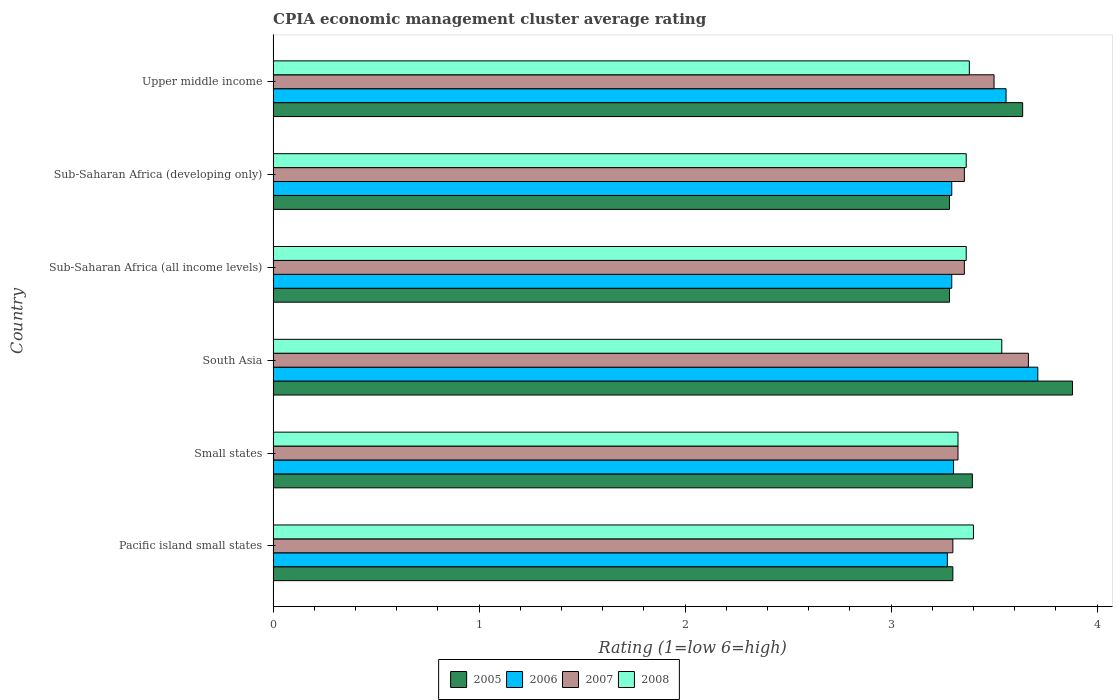How many different coloured bars are there?
Make the answer very short. 4. Are the number of bars per tick equal to the number of legend labels?
Make the answer very short. Yes. What is the label of the 2nd group of bars from the top?
Provide a succinct answer. Sub-Saharan Africa (developing only). What is the CPIA rating in 2008 in Small states?
Your response must be concise. 3.33. Across all countries, what is the maximum CPIA rating in 2008?
Offer a terse response. 3.54. Across all countries, what is the minimum CPIA rating in 2008?
Ensure brevity in your answer.  3.33. In which country was the CPIA rating in 2008 maximum?
Keep it short and to the point. South Asia. In which country was the CPIA rating in 2006 minimum?
Your answer should be compact. Pacific island small states. What is the total CPIA rating in 2006 in the graph?
Your response must be concise. 20.44. What is the difference between the CPIA rating in 2008 in Small states and that in Sub-Saharan Africa (developing only)?
Make the answer very short. -0.04. What is the difference between the CPIA rating in 2006 in South Asia and the CPIA rating in 2008 in Small states?
Offer a very short reply. 0.39. What is the average CPIA rating in 2007 per country?
Your response must be concise. 3.42. What is the difference between the CPIA rating in 2007 and CPIA rating in 2008 in Sub-Saharan Africa (all income levels)?
Offer a terse response. -0.01. In how many countries, is the CPIA rating in 2008 greater than 2.8 ?
Keep it short and to the point. 6. What is the ratio of the CPIA rating in 2006 in Small states to that in Upper middle income?
Your answer should be compact. 0.93. Is the difference between the CPIA rating in 2007 in South Asia and Upper middle income greater than the difference between the CPIA rating in 2008 in South Asia and Upper middle income?
Your answer should be very brief. Yes. What is the difference between the highest and the second highest CPIA rating in 2006?
Offer a very short reply. 0.15. What is the difference between the highest and the lowest CPIA rating in 2006?
Your response must be concise. 0.44. Is it the case that in every country, the sum of the CPIA rating in 2008 and CPIA rating in 2006 is greater than the sum of CPIA rating in 2007 and CPIA rating in 2005?
Your answer should be very brief. No. What does the 2nd bar from the top in Pacific island small states represents?
Your response must be concise. 2007. Is it the case that in every country, the sum of the CPIA rating in 2007 and CPIA rating in 2005 is greater than the CPIA rating in 2008?
Ensure brevity in your answer.  Yes. Where does the legend appear in the graph?
Offer a very short reply. Bottom center. How are the legend labels stacked?
Provide a short and direct response. Horizontal. What is the title of the graph?
Your response must be concise. CPIA economic management cluster average rating. Does "1998" appear as one of the legend labels in the graph?
Offer a terse response. No. What is the label or title of the Y-axis?
Your response must be concise. Country. What is the Rating (1=low 6=high) of 2006 in Pacific island small states?
Your answer should be compact. 3.27. What is the Rating (1=low 6=high) of 2005 in Small states?
Provide a short and direct response. 3.39. What is the Rating (1=low 6=high) of 2006 in Small states?
Your answer should be compact. 3.3. What is the Rating (1=low 6=high) of 2007 in Small states?
Your answer should be very brief. 3.33. What is the Rating (1=low 6=high) of 2008 in Small states?
Provide a short and direct response. 3.33. What is the Rating (1=low 6=high) in 2005 in South Asia?
Make the answer very short. 3.88. What is the Rating (1=low 6=high) of 2006 in South Asia?
Provide a short and direct response. 3.71. What is the Rating (1=low 6=high) in 2007 in South Asia?
Provide a short and direct response. 3.67. What is the Rating (1=low 6=high) in 2008 in South Asia?
Your response must be concise. 3.54. What is the Rating (1=low 6=high) in 2005 in Sub-Saharan Africa (all income levels)?
Ensure brevity in your answer.  3.28. What is the Rating (1=low 6=high) in 2006 in Sub-Saharan Africa (all income levels)?
Your answer should be very brief. 3.29. What is the Rating (1=low 6=high) in 2007 in Sub-Saharan Africa (all income levels)?
Keep it short and to the point. 3.36. What is the Rating (1=low 6=high) in 2008 in Sub-Saharan Africa (all income levels)?
Provide a short and direct response. 3.36. What is the Rating (1=low 6=high) of 2005 in Sub-Saharan Africa (developing only)?
Provide a short and direct response. 3.28. What is the Rating (1=low 6=high) of 2006 in Sub-Saharan Africa (developing only)?
Keep it short and to the point. 3.29. What is the Rating (1=low 6=high) of 2007 in Sub-Saharan Africa (developing only)?
Keep it short and to the point. 3.36. What is the Rating (1=low 6=high) of 2008 in Sub-Saharan Africa (developing only)?
Offer a very short reply. 3.36. What is the Rating (1=low 6=high) in 2005 in Upper middle income?
Your answer should be compact. 3.64. What is the Rating (1=low 6=high) in 2006 in Upper middle income?
Your answer should be very brief. 3.56. What is the Rating (1=low 6=high) of 2008 in Upper middle income?
Provide a succinct answer. 3.38. Across all countries, what is the maximum Rating (1=low 6=high) of 2005?
Provide a short and direct response. 3.88. Across all countries, what is the maximum Rating (1=low 6=high) of 2006?
Your response must be concise. 3.71. Across all countries, what is the maximum Rating (1=low 6=high) of 2007?
Give a very brief answer. 3.67. Across all countries, what is the maximum Rating (1=low 6=high) in 2008?
Offer a very short reply. 3.54. Across all countries, what is the minimum Rating (1=low 6=high) in 2005?
Your answer should be compact. 3.28. Across all countries, what is the minimum Rating (1=low 6=high) in 2006?
Offer a very short reply. 3.27. Across all countries, what is the minimum Rating (1=low 6=high) of 2008?
Provide a short and direct response. 3.33. What is the total Rating (1=low 6=high) in 2005 in the graph?
Provide a short and direct response. 20.78. What is the total Rating (1=low 6=high) in 2006 in the graph?
Your answer should be compact. 20.44. What is the total Rating (1=low 6=high) in 2007 in the graph?
Your answer should be compact. 20.5. What is the total Rating (1=low 6=high) in 2008 in the graph?
Your response must be concise. 20.37. What is the difference between the Rating (1=low 6=high) of 2005 in Pacific island small states and that in Small states?
Provide a succinct answer. -0.09. What is the difference between the Rating (1=low 6=high) in 2006 in Pacific island small states and that in Small states?
Provide a short and direct response. -0.03. What is the difference between the Rating (1=low 6=high) of 2007 in Pacific island small states and that in Small states?
Your response must be concise. -0.03. What is the difference between the Rating (1=low 6=high) in 2008 in Pacific island small states and that in Small states?
Provide a succinct answer. 0.07. What is the difference between the Rating (1=low 6=high) in 2005 in Pacific island small states and that in South Asia?
Provide a short and direct response. -0.58. What is the difference between the Rating (1=low 6=high) in 2006 in Pacific island small states and that in South Asia?
Make the answer very short. -0.44. What is the difference between the Rating (1=low 6=high) of 2007 in Pacific island small states and that in South Asia?
Provide a short and direct response. -0.37. What is the difference between the Rating (1=low 6=high) in 2008 in Pacific island small states and that in South Asia?
Provide a short and direct response. -0.14. What is the difference between the Rating (1=low 6=high) of 2005 in Pacific island small states and that in Sub-Saharan Africa (all income levels)?
Your answer should be compact. 0.02. What is the difference between the Rating (1=low 6=high) of 2006 in Pacific island small states and that in Sub-Saharan Africa (all income levels)?
Your answer should be very brief. -0.02. What is the difference between the Rating (1=low 6=high) of 2007 in Pacific island small states and that in Sub-Saharan Africa (all income levels)?
Provide a succinct answer. -0.06. What is the difference between the Rating (1=low 6=high) of 2008 in Pacific island small states and that in Sub-Saharan Africa (all income levels)?
Ensure brevity in your answer.  0.04. What is the difference between the Rating (1=low 6=high) of 2005 in Pacific island small states and that in Sub-Saharan Africa (developing only)?
Ensure brevity in your answer.  0.02. What is the difference between the Rating (1=low 6=high) in 2006 in Pacific island small states and that in Sub-Saharan Africa (developing only)?
Keep it short and to the point. -0.02. What is the difference between the Rating (1=low 6=high) of 2007 in Pacific island small states and that in Sub-Saharan Africa (developing only)?
Make the answer very short. -0.06. What is the difference between the Rating (1=low 6=high) of 2008 in Pacific island small states and that in Sub-Saharan Africa (developing only)?
Give a very brief answer. 0.04. What is the difference between the Rating (1=low 6=high) in 2005 in Pacific island small states and that in Upper middle income?
Offer a terse response. -0.34. What is the difference between the Rating (1=low 6=high) in 2006 in Pacific island small states and that in Upper middle income?
Provide a succinct answer. -0.28. What is the difference between the Rating (1=low 6=high) of 2005 in Small states and that in South Asia?
Make the answer very short. -0.49. What is the difference between the Rating (1=low 6=high) of 2006 in Small states and that in South Asia?
Your answer should be compact. -0.41. What is the difference between the Rating (1=low 6=high) of 2007 in Small states and that in South Asia?
Keep it short and to the point. -0.34. What is the difference between the Rating (1=low 6=high) of 2008 in Small states and that in South Asia?
Offer a terse response. -0.21. What is the difference between the Rating (1=low 6=high) of 2005 in Small states and that in Sub-Saharan Africa (all income levels)?
Offer a very short reply. 0.11. What is the difference between the Rating (1=low 6=high) of 2006 in Small states and that in Sub-Saharan Africa (all income levels)?
Your answer should be compact. 0.01. What is the difference between the Rating (1=low 6=high) in 2007 in Small states and that in Sub-Saharan Africa (all income levels)?
Make the answer very short. -0.03. What is the difference between the Rating (1=low 6=high) in 2008 in Small states and that in Sub-Saharan Africa (all income levels)?
Give a very brief answer. -0.04. What is the difference between the Rating (1=low 6=high) in 2005 in Small states and that in Sub-Saharan Africa (developing only)?
Provide a succinct answer. 0.11. What is the difference between the Rating (1=low 6=high) in 2006 in Small states and that in Sub-Saharan Africa (developing only)?
Your answer should be very brief. 0.01. What is the difference between the Rating (1=low 6=high) of 2007 in Small states and that in Sub-Saharan Africa (developing only)?
Provide a short and direct response. -0.03. What is the difference between the Rating (1=low 6=high) of 2008 in Small states and that in Sub-Saharan Africa (developing only)?
Provide a succinct answer. -0.04. What is the difference between the Rating (1=low 6=high) of 2005 in Small states and that in Upper middle income?
Ensure brevity in your answer.  -0.24. What is the difference between the Rating (1=low 6=high) of 2006 in Small states and that in Upper middle income?
Keep it short and to the point. -0.26. What is the difference between the Rating (1=low 6=high) in 2007 in Small states and that in Upper middle income?
Make the answer very short. -0.17. What is the difference between the Rating (1=low 6=high) in 2008 in Small states and that in Upper middle income?
Your response must be concise. -0.06. What is the difference between the Rating (1=low 6=high) of 2005 in South Asia and that in Sub-Saharan Africa (all income levels)?
Give a very brief answer. 0.6. What is the difference between the Rating (1=low 6=high) in 2006 in South Asia and that in Sub-Saharan Africa (all income levels)?
Your response must be concise. 0.42. What is the difference between the Rating (1=low 6=high) in 2007 in South Asia and that in Sub-Saharan Africa (all income levels)?
Offer a terse response. 0.31. What is the difference between the Rating (1=low 6=high) in 2008 in South Asia and that in Sub-Saharan Africa (all income levels)?
Make the answer very short. 0.17. What is the difference between the Rating (1=low 6=high) in 2005 in South Asia and that in Sub-Saharan Africa (developing only)?
Your response must be concise. 0.6. What is the difference between the Rating (1=low 6=high) in 2006 in South Asia and that in Sub-Saharan Africa (developing only)?
Make the answer very short. 0.42. What is the difference between the Rating (1=low 6=high) of 2007 in South Asia and that in Sub-Saharan Africa (developing only)?
Ensure brevity in your answer.  0.31. What is the difference between the Rating (1=low 6=high) in 2008 in South Asia and that in Sub-Saharan Africa (developing only)?
Make the answer very short. 0.17. What is the difference between the Rating (1=low 6=high) of 2005 in South Asia and that in Upper middle income?
Provide a short and direct response. 0.24. What is the difference between the Rating (1=low 6=high) of 2006 in South Asia and that in Upper middle income?
Your answer should be very brief. 0.15. What is the difference between the Rating (1=low 6=high) in 2007 in South Asia and that in Upper middle income?
Keep it short and to the point. 0.17. What is the difference between the Rating (1=low 6=high) of 2008 in South Asia and that in Upper middle income?
Offer a terse response. 0.16. What is the difference between the Rating (1=low 6=high) in 2006 in Sub-Saharan Africa (all income levels) and that in Sub-Saharan Africa (developing only)?
Keep it short and to the point. 0. What is the difference between the Rating (1=low 6=high) of 2005 in Sub-Saharan Africa (all income levels) and that in Upper middle income?
Make the answer very short. -0.36. What is the difference between the Rating (1=low 6=high) in 2006 in Sub-Saharan Africa (all income levels) and that in Upper middle income?
Ensure brevity in your answer.  -0.26. What is the difference between the Rating (1=low 6=high) in 2007 in Sub-Saharan Africa (all income levels) and that in Upper middle income?
Provide a succinct answer. -0.14. What is the difference between the Rating (1=low 6=high) in 2008 in Sub-Saharan Africa (all income levels) and that in Upper middle income?
Keep it short and to the point. -0.02. What is the difference between the Rating (1=low 6=high) of 2005 in Sub-Saharan Africa (developing only) and that in Upper middle income?
Offer a terse response. -0.36. What is the difference between the Rating (1=low 6=high) in 2006 in Sub-Saharan Africa (developing only) and that in Upper middle income?
Your response must be concise. -0.26. What is the difference between the Rating (1=low 6=high) of 2007 in Sub-Saharan Africa (developing only) and that in Upper middle income?
Provide a short and direct response. -0.14. What is the difference between the Rating (1=low 6=high) in 2008 in Sub-Saharan Africa (developing only) and that in Upper middle income?
Ensure brevity in your answer.  -0.02. What is the difference between the Rating (1=low 6=high) of 2005 in Pacific island small states and the Rating (1=low 6=high) of 2006 in Small states?
Your answer should be very brief. -0. What is the difference between the Rating (1=low 6=high) of 2005 in Pacific island small states and the Rating (1=low 6=high) of 2007 in Small states?
Offer a very short reply. -0.03. What is the difference between the Rating (1=low 6=high) in 2005 in Pacific island small states and the Rating (1=low 6=high) in 2008 in Small states?
Provide a succinct answer. -0.03. What is the difference between the Rating (1=low 6=high) in 2006 in Pacific island small states and the Rating (1=low 6=high) in 2007 in Small states?
Keep it short and to the point. -0.05. What is the difference between the Rating (1=low 6=high) of 2006 in Pacific island small states and the Rating (1=low 6=high) of 2008 in Small states?
Give a very brief answer. -0.05. What is the difference between the Rating (1=low 6=high) of 2007 in Pacific island small states and the Rating (1=low 6=high) of 2008 in Small states?
Keep it short and to the point. -0.03. What is the difference between the Rating (1=low 6=high) of 2005 in Pacific island small states and the Rating (1=low 6=high) of 2006 in South Asia?
Offer a terse response. -0.41. What is the difference between the Rating (1=low 6=high) in 2005 in Pacific island small states and the Rating (1=low 6=high) in 2007 in South Asia?
Your response must be concise. -0.37. What is the difference between the Rating (1=low 6=high) in 2005 in Pacific island small states and the Rating (1=low 6=high) in 2008 in South Asia?
Give a very brief answer. -0.24. What is the difference between the Rating (1=low 6=high) in 2006 in Pacific island small states and the Rating (1=low 6=high) in 2007 in South Asia?
Offer a very short reply. -0.39. What is the difference between the Rating (1=low 6=high) of 2006 in Pacific island small states and the Rating (1=low 6=high) of 2008 in South Asia?
Your answer should be compact. -0.26. What is the difference between the Rating (1=low 6=high) in 2007 in Pacific island small states and the Rating (1=low 6=high) in 2008 in South Asia?
Offer a very short reply. -0.24. What is the difference between the Rating (1=low 6=high) of 2005 in Pacific island small states and the Rating (1=low 6=high) of 2006 in Sub-Saharan Africa (all income levels)?
Provide a short and direct response. 0.01. What is the difference between the Rating (1=low 6=high) in 2005 in Pacific island small states and the Rating (1=low 6=high) in 2007 in Sub-Saharan Africa (all income levels)?
Offer a very short reply. -0.06. What is the difference between the Rating (1=low 6=high) in 2005 in Pacific island small states and the Rating (1=low 6=high) in 2008 in Sub-Saharan Africa (all income levels)?
Your answer should be very brief. -0.06. What is the difference between the Rating (1=low 6=high) in 2006 in Pacific island small states and the Rating (1=low 6=high) in 2007 in Sub-Saharan Africa (all income levels)?
Offer a very short reply. -0.08. What is the difference between the Rating (1=low 6=high) in 2006 in Pacific island small states and the Rating (1=low 6=high) in 2008 in Sub-Saharan Africa (all income levels)?
Your answer should be compact. -0.09. What is the difference between the Rating (1=low 6=high) in 2007 in Pacific island small states and the Rating (1=low 6=high) in 2008 in Sub-Saharan Africa (all income levels)?
Offer a terse response. -0.06. What is the difference between the Rating (1=low 6=high) of 2005 in Pacific island small states and the Rating (1=low 6=high) of 2006 in Sub-Saharan Africa (developing only)?
Ensure brevity in your answer.  0.01. What is the difference between the Rating (1=low 6=high) in 2005 in Pacific island small states and the Rating (1=low 6=high) in 2007 in Sub-Saharan Africa (developing only)?
Offer a terse response. -0.06. What is the difference between the Rating (1=low 6=high) in 2005 in Pacific island small states and the Rating (1=low 6=high) in 2008 in Sub-Saharan Africa (developing only)?
Provide a short and direct response. -0.06. What is the difference between the Rating (1=low 6=high) of 2006 in Pacific island small states and the Rating (1=low 6=high) of 2007 in Sub-Saharan Africa (developing only)?
Your response must be concise. -0.08. What is the difference between the Rating (1=low 6=high) in 2006 in Pacific island small states and the Rating (1=low 6=high) in 2008 in Sub-Saharan Africa (developing only)?
Provide a short and direct response. -0.09. What is the difference between the Rating (1=low 6=high) of 2007 in Pacific island small states and the Rating (1=low 6=high) of 2008 in Sub-Saharan Africa (developing only)?
Offer a very short reply. -0.06. What is the difference between the Rating (1=low 6=high) in 2005 in Pacific island small states and the Rating (1=low 6=high) in 2006 in Upper middle income?
Offer a terse response. -0.26. What is the difference between the Rating (1=low 6=high) in 2005 in Pacific island small states and the Rating (1=low 6=high) in 2008 in Upper middle income?
Give a very brief answer. -0.08. What is the difference between the Rating (1=low 6=high) of 2006 in Pacific island small states and the Rating (1=low 6=high) of 2007 in Upper middle income?
Your answer should be compact. -0.23. What is the difference between the Rating (1=low 6=high) of 2006 in Pacific island small states and the Rating (1=low 6=high) of 2008 in Upper middle income?
Provide a succinct answer. -0.11. What is the difference between the Rating (1=low 6=high) of 2007 in Pacific island small states and the Rating (1=low 6=high) of 2008 in Upper middle income?
Provide a succinct answer. -0.08. What is the difference between the Rating (1=low 6=high) of 2005 in Small states and the Rating (1=low 6=high) of 2006 in South Asia?
Your answer should be very brief. -0.32. What is the difference between the Rating (1=low 6=high) of 2005 in Small states and the Rating (1=low 6=high) of 2007 in South Asia?
Offer a terse response. -0.27. What is the difference between the Rating (1=low 6=high) of 2005 in Small states and the Rating (1=low 6=high) of 2008 in South Asia?
Offer a terse response. -0.14. What is the difference between the Rating (1=low 6=high) in 2006 in Small states and the Rating (1=low 6=high) in 2007 in South Asia?
Offer a very short reply. -0.36. What is the difference between the Rating (1=low 6=high) in 2006 in Small states and the Rating (1=low 6=high) in 2008 in South Asia?
Ensure brevity in your answer.  -0.23. What is the difference between the Rating (1=low 6=high) in 2007 in Small states and the Rating (1=low 6=high) in 2008 in South Asia?
Provide a succinct answer. -0.21. What is the difference between the Rating (1=low 6=high) of 2005 in Small states and the Rating (1=low 6=high) of 2006 in Sub-Saharan Africa (all income levels)?
Make the answer very short. 0.1. What is the difference between the Rating (1=low 6=high) of 2005 in Small states and the Rating (1=low 6=high) of 2007 in Sub-Saharan Africa (all income levels)?
Make the answer very short. 0.04. What is the difference between the Rating (1=low 6=high) in 2005 in Small states and the Rating (1=low 6=high) in 2008 in Sub-Saharan Africa (all income levels)?
Offer a terse response. 0.03. What is the difference between the Rating (1=low 6=high) in 2006 in Small states and the Rating (1=low 6=high) in 2007 in Sub-Saharan Africa (all income levels)?
Your response must be concise. -0.05. What is the difference between the Rating (1=low 6=high) in 2006 in Small states and the Rating (1=low 6=high) in 2008 in Sub-Saharan Africa (all income levels)?
Ensure brevity in your answer.  -0.06. What is the difference between the Rating (1=low 6=high) in 2007 in Small states and the Rating (1=low 6=high) in 2008 in Sub-Saharan Africa (all income levels)?
Offer a very short reply. -0.04. What is the difference between the Rating (1=low 6=high) of 2005 in Small states and the Rating (1=low 6=high) of 2006 in Sub-Saharan Africa (developing only)?
Give a very brief answer. 0.1. What is the difference between the Rating (1=low 6=high) of 2005 in Small states and the Rating (1=low 6=high) of 2007 in Sub-Saharan Africa (developing only)?
Offer a terse response. 0.04. What is the difference between the Rating (1=low 6=high) in 2005 in Small states and the Rating (1=low 6=high) in 2008 in Sub-Saharan Africa (developing only)?
Give a very brief answer. 0.03. What is the difference between the Rating (1=low 6=high) in 2006 in Small states and the Rating (1=low 6=high) in 2007 in Sub-Saharan Africa (developing only)?
Give a very brief answer. -0.05. What is the difference between the Rating (1=low 6=high) of 2006 in Small states and the Rating (1=low 6=high) of 2008 in Sub-Saharan Africa (developing only)?
Provide a short and direct response. -0.06. What is the difference between the Rating (1=low 6=high) in 2007 in Small states and the Rating (1=low 6=high) in 2008 in Sub-Saharan Africa (developing only)?
Provide a short and direct response. -0.04. What is the difference between the Rating (1=low 6=high) in 2005 in Small states and the Rating (1=low 6=high) in 2006 in Upper middle income?
Ensure brevity in your answer.  -0.16. What is the difference between the Rating (1=low 6=high) of 2005 in Small states and the Rating (1=low 6=high) of 2007 in Upper middle income?
Your answer should be compact. -0.11. What is the difference between the Rating (1=low 6=high) of 2005 in Small states and the Rating (1=low 6=high) of 2008 in Upper middle income?
Provide a succinct answer. 0.01. What is the difference between the Rating (1=low 6=high) in 2006 in Small states and the Rating (1=low 6=high) in 2007 in Upper middle income?
Ensure brevity in your answer.  -0.2. What is the difference between the Rating (1=low 6=high) of 2006 in Small states and the Rating (1=low 6=high) of 2008 in Upper middle income?
Provide a succinct answer. -0.08. What is the difference between the Rating (1=low 6=high) in 2007 in Small states and the Rating (1=low 6=high) in 2008 in Upper middle income?
Give a very brief answer. -0.06. What is the difference between the Rating (1=low 6=high) of 2005 in South Asia and the Rating (1=low 6=high) of 2006 in Sub-Saharan Africa (all income levels)?
Ensure brevity in your answer.  0.59. What is the difference between the Rating (1=low 6=high) in 2005 in South Asia and the Rating (1=low 6=high) in 2007 in Sub-Saharan Africa (all income levels)?
Your response must be concise. 0.53. What is the difference between the Rating (1=low 6=high) of 2005 in South Asia and the Rating (1=low 6=high) of 2008 in Sub-Saharan Africa (all income levels)?
Give a very brief answer. 0.52. What is the difference between the Rating (1=low 6=high) in 2006 in South Asia and the Rating (1=low 6=high) in 2007 in Sub-Saharan Africa (all income levels)?
Ensure brevity in your answer.  0.36. What is the difference between the Rating (1=low 6=high) in 2006 in South Asia and the Rating (1=low 6=high) in 2008 in Sub-Saharan Africa (all income levels)?
Give a very brief answer. 0.35. What is the difference between the Rating (1=low 6=high) of 2007 in South Asia and the Rating (1=low 6=high) of 2008 in Sub-Saharan Africa (all income levels)?
Provide a short and direct response. 0.3. What is the difference between the Rating (1=low 6=high) in 2005 in South Asia and the Rating (1=low 6=high) in 2006 in Sub-Saharan Africa (developing only)?
Your answer should be compact. 0.59. What is the difference between the Rating (1=low 6=high) of 2005 in South Asia and the Rating (1=low 6=high) of 2007 in Sub-Saharan Africa (developing only)?
Your answer should be compact. 0.53. What is the difference between the Rating (1=low 6=high) in 2005 in South Asia and the Rating (1=low 6=high) in 2008 in Sub-Saharan Africa (developing only)?
Make the answer very short. 0.52. What is the difference between the Rating (1=low 6=high) of 2006 in South Asia and the Rating (1=low 6=high) of 2007 in Sub-Saharan Africa (developing only)?
Your answer should be very brief. 0.36. What is the difference between the Rating (1=low 6=high) in 2006 in South Asia and the Rating (1=low 6=high) in 2008 in Sub-Saharan Africa (developing only)?
Keep it short and to the point. 0.35. What is the difference between the Rating (1=low 6=high) in 2007 in South Asia and the Rating (1=low 6=high) in 2008 in Sub-Saharan Africa (developing only)?
Keep it short and to the point. 0.3. What is the difference between the Rating (1=low 6=high) in 2005 in South Asia and the Rating (1=low 6=high) in 2006 in Upper middle income?
Offer a very short reply. 0.32. What is the difference between the Rating (1=low 6=high) of 2005 in South Asia and the Rating (1=low 6=high) of 2007 in Upper middle income?
Provide a short and direct response. 0.38. What is the difference between the Rating (1=low 6=high) of 2005 in South Asia and the Rating (1=low 6=high) of 2008 in Upper middle income?
Give a very brief answer. 0.5. What is the difference between the Rating (1=low 6=high) in 2006 in South Asia and the Rating (1=low 6=high) in 2007 in Upper middle income?
Give a very brief answer. 0.21. What is the difference between the Rating (1=low 6=high) in 2006 in South Asia and the Rating (1=low 6=high) in 2008 in Upper middle income?
Give a very brief answer. 0.33. What is the difference between the Rating (1=low 6=high) in 2007 in South Asia and the Rating (1=low 6=high) in 2008 in Upper middle income?
Make the answer very short. 0.29. What is the difference between the Rating (1=low 6=high) in 2005 in Sub-Saharan Africa (all income levels) and the Rating (1=low 6=high) in 2006 in Sub-Saharan Africa (developing only)?
Offer a terse response. -0.01. What is the difference between the Rating (1=low 6=high) in 2005 in Sub-Saharan Africa (all income levels) and the Rating (1=low 6=high) in 2007 in Sub-Saharan Africa (developing only)?
Offer a terse response. -0.07. What is the difference between the Rating (1=low 6=high) in 2005 in Sub-Saharan Africa (all income levels) and the Rating (1=low 6=high) in 2008 in Sub-Saharan Africa (developing only)?
Give a very brief answer. -0.08. What is the difference between the Rating (1=low 6=high) in 2006 in Sub-Saharan Africa (all income levels) and the Rating (1=low 6=high) in 2007 in Sub-Saharan Africa (developing only)?
Give a very brief answer. -0.06. What is the difference between the Rating (1=low 6=high) in 2006 in Sub-Saharan Africa (all income levels) and the Rating (1=low 6=high) in 2008 in Sub-Saharan Africa (developing only)?
Provide a short and direct response. -0.07. What is the difference between the Rating (1=low 6=high) of 2007 in Sub-Saharan Africa (all income levels) and the Rating (1=low 6=high) of 2008 in Sub-Saharan Africa (developing only)?
Your answer should be very brief. -0.01. What is the difference between the Rating (1=low 6=high) in 2005 in Sub-Saharan Africa (all income levels) and the Rating (1=low 6=high) in 2006 in Upper middle income?
Give a very brief answer. -0.27. What is the difference between the Rating (1=low 6=high) in 2005 in Sub-Saharan Africa (all income levels) and the Rating (1=low 6=high) in 2007 in Upper middle income?
Provide a short and direct response. -0.22. What is the difference between the Rating (1=low 6=high) in 2005 in Sub-Saharan Africa (all income levels) and the Rating (1=low 6=high) in 2008 in Upper middle income?
Ensure brevity in your answer.  -0.1. What is the difference between the Rating (1=low 6=high) of 2006 in Sub-Saharan Africa (all income levels) and the Rating (1=low 6=high) of 2007 in Upper middle income?
Make the answer very short. -0.21. What is the difference between the Rating (1=low 6=high) in 2006 in Sub-Saharan Africa (all income levels) and the Rating (1=low 6=high) in 2008 in Upper middle income?
Ensure brevity in your answer.  -0.09. What is the difference between the Rating (1=low 6=high) of 2007 in Sub-Saharan Africa (all income levels) and the Rating (1=low 6=high) of 2008 in Upper middle income?
Give a very brief answer. -0.02. What is the difference between the Rating (1=low 6=high) of 2005 in Sub-Saharan Africa (developing only) and the Rating (1=low 6=high) of 2006 in Upper middle income?
Provide a succinct answer. -0.27. What is the difference between the Rating (1=low 6=high) of 2005 in Sub-Saharan Africa (developing only) and the Rating (1=low 6=high) of 2007 in Upper middle income?
Offer a very short reply. -0.22. What is the difference between the Rating (1=low 6=high) in 2005 in Sub-Saharan Africa (developing only) and the Rating (1=low 6=high) in 2008 in Upper middle income?
Provide a succinct answer. -0.1. What is the difference between the Rating (1=low 6=high) of 2006 in Sub-Saharan Africa (developing only) and the Rating (1=low 6=high) of 2007 in Upper middle income?
Offer a very short reply. -0.21. What is the difference between the Rating (1=low 6=high) of 2006 in Sub-Saharan Africa (developing only) and the Rating (1=low 6=high) of 2008 in Upper middle income?
Your answer should be very brief. -0.09. What is the difference between the Rating (1=low 6=high) in 2007 in Sub-Saharan Africa (developing only) and the Rating (1=low 6=high) in 2008 in Upper middle income?
Give a very brief answer. -0.02. What is the average Rating (1=low 6=high) of 2005 per country?
Give a very brief answer. 3.46. What is the average Rating (1=low 6=high) in 2006 per country?
Make the answer very short. 3.41. What is the average Rating (1=low 6=high) of 2007 per country?
Your answer should be compact. 3.42. What is the average Rating (1=low 6=high) in 2008 per country?
Provide a short and direct response. 3.4. What is the difference between the Rating (1=low 6=high) of 2005 and Rating (1=low 6=high) of 2006 in Pacific island small states?
Your response must be concise. 0.03. What is the difference between the Rating (1=low 6=high) in 2005 and Rating (1=low 6=high) in 2008 in Pacific island small states?
Provide a short and direct response. -0.1. What is the difference between the Rating (1=low 6=high) of 2006 and Rating (1=low 6=high) of 2007 in Pacific island small states?
Give a very brief answer. -0.03. What is the difference between the Rating (1=low 6=high) in 2006 and Rating (1=low 6=high) in 2008 in Pacific island small states?
Ensure brevity in your answer.  -0.13. What is the difference between the Rating (1=low 6=high) in 2005 and Rating (1=low 6=high) in 2006 in Small states?
Your response must be concise. 0.09. What is the difference between the Rating (1=low 6=high) of 2005 and Rating (1=low 6=high) of 2007 in Small states?
Your response must be concise. 0.07. What is the difference between the Rating (1=low 6=high) in 2005 and Rating (1=low 6=high) in 2008 in Small states?
Ensure brevity in your answer.  0.07. What is the difference between the Rating (1=low 6=high) in 2006 and Rating (1=low 6=high) in 2007 in Small states?
Offer a terse response. -0.02. What is the difference between the Rating (1=low 6=high) of 2006 and Rating (1=low 6=high) of 2008 in Small states?
Keep it short and to the point. -0.02. What is the difference between the Rating (1=low 6=high) in 2005 and Rating (1=low 6=high) in 2006 in South Asia?
Ensure brevity in your answer.  0.17. What is the difference between the Rating (1=low 6=high) of 2005 and Rating (1=low 6=high) of 2007 in South Asia?
Provide a succinct answer. 0.21. What is the difference between the Rating (1=low 6=high) of 2005 and Rating (1=low 6=high) of 2008 in South Asia?
Give a very brief answer. 0.34. What is the difference between the Rating (1=low 6=high) in 2006 and Rating (1=low 6=high) in 2007 in South Asia?
Your answer should be compact. 0.05. What is the difference between the Rating (1=low 6=high) in 2006 and Rating (1=low 6=high) in 2008 in South Asia?
Offer a terse response. 0.17. What is the difference between the Rating (1=low 6=high) of 2007 and Rating (1=low 6=high) of 2008 in South Asia?
Your answer should be very brief. 0.13. What is the difference between the Rating (1=low 6=high) in 2005 and Rating (1=low 6=high) in 2006 in Sub-Saharan Africa (all income levels)?
Your response must be concise. -0.01. What is the difference between the Rating (1=low 6=high) in 2005 and Rating (1=low 6=high) in 2007 in Sub-Saharan Africa (all income levels)?
Your answer should be compact. -0.07. What is the difference between the Rating (1=low 6=high) in 2005 and Rating (1=low 6=high) in 2008 in Sub-Saharan Africa (all income levels)?
Provide a short and direct response. -0.08. What is the difference between the Rating (1=low 6=high) of 2006 and Rating (1=low 6=high) of 2007 in Sub-Saharan Africa (all income levels)?
Give a very brief answer. -0.06. What is the difference between the Rating (1=low 6=high) of 2006 and Rating (1=low 6=high) of 2008 in Sub-Saharan Africa (all income levels)?
Your answer should be very brief. -0.07. What is the difference between the Rating (1=low 6=high) in 2007 and Rating (1=low 6=high) in 2008 in Sub-Saharan Africa (all income levels)?
Keep it short and to the point. -0.01. What is the difference between the Rating (1=low 6=high) in 2005 and Rating (1=low 6=high) in 2006 in Sub-Saharan Africa (developing only)?
Your answer should be compact. -0.01. What is the difference between the Rating (1=low 6=high) in 2005 and Rating (1=low 6=high) in 2007 in Sub-Saharan Africa (developing only)?
Offer a terse response. -0.07. What is the difference between the Rating (1=low 6=high) of 2005 and Rating (1=low 6=high) of 2008 in Sub-Saharan Africa (developing only)?
Make the answer very short. -0.08. What is the difference between the Rating (1=low 6=high) in 2006 and Rating (1=low 6=high) in 2007 in Sub-Saharan Africa (developing only)?
Provide a succinct answer. -0.06. What is the difference between the Rating (1=low 6=high) of 2006 and Rating (1=low 6=high) of 2008 in Sub-Saharan Africa (developing only)?
Your response must be concise. -0.07. What is the difference between the Rating (1=low 6=high) in 2007 and Rating (1=low 6=high) in 2008 in Sub-Saharan Africa (developing only)?
Your answer should be compact. -0.01. What is the difference between the Rating (1=low 6=high) of 2005 and Rating (1=low 6=high) of 2006 in Upper middle income?
Provide a short and direct response. 0.08. What is the difference between the Rating (1=low 6=high) of 2005 and Rating (1=low 6=high) of 2007 in Upper middle income?
Give a very brief answer. 0.14. What is the difference between the Rating (1=low 6=high) in 2005 and Rating (1=low 6=high) in 2008 in Upper middle income?
Make the answer very short. 0.26. What is the difference between the Rating (1=low 6=high) in 2006 and Rating (1=low 6=high) in 2007 in Upper middle income?
Your answer should be compact. 0.06. What is the difference between the Rating (1=low 6=high) of 2006 and Rating (1=low 6=high) of 2008 in Upper middle income?
Keep it short and to the point. 0.18. What is the difference between the Rating (1=low 6=high) in 2007 and Rating (1=low 6=high) in 2008 in Upper middle income?
Your response must be concise. 0.12. What is the ratio of the Rating (1=low 6=high) in 2005 in Pacific island small states to that in Small states?
Your answer should be very brief. 0.97. What is the ratio of the Rating (1=low 6=high) in 2006 in Pacific island small states to that in Small states?
Provide a succinct answer. 0.99. What is the ratio of the Rating (1=low 6=high) of 2008 in Pacific island small states to that in Small states?
Your answer should be compact. 1.02. What is the ratio of the Rating (1=low 6=high) in 2005 in Pacific island small states to that in South Asia?
Offer a terse response. 0.85. What is the ratio of the Rating (1=low 6=high) in 2006 in Pacific island small states to that in South Asia?
Your answer should be compact. 0.88. What is the ratio of the Rating (1=low 6=high) in 2007 in Pacific island small states to that in South Asia?
Make the answer very short. 0.9. What is the ratio of the Rating (1=low 6=high) in 2008 in Pacific island small states to that in South Asia?
Make the answer very short. 0.96. What is the ratio of the Rating (1=low 6=high) of 2005 in Pacific island small states to that in Sub-Saharan Africa (all income levels)?
Your answer should be compact. 1. What is the ratio of the Rating (1=low 6=high) in 2006 in Pacific island small states to that in Sub-Saharan Africa (all income levels)?
Your answer should be very brief. 0.99. What is the ratio of the Rating (1=low 6=high) of 2007 in Pacific island small states to that in Sub-Saharan Africa (all income levels)?
Offer a terse response. 0.98. What is the ratio of the Rating (1=low 6=high) in 2008 in Pacific island small states to that in Sub-Saharan Africa (all income levels)?
Make the answer very short. 1.01. What is the ratio of the Rating (1=low 6=high) in 2005 in Pacific island small states to that in Sub-Saharan Africa (developing only)?
Your answer should be very brief. 1. What is the ratio of the Rating (1=low 6=high) of 2006 in Pacific island small states to that in Sub-Saharan Africa (developing only)?
Your answer should be compact. 0.99. What is the ratio of the Rating (1=low 6=high) in 2007 in Pacific island small states to that in Sub-Saharan Africa (developing only)?
Ensure brevity in your answer.  0.98. What is the ratio of the Rating (1=low 6=high) in 2008 in Pacific island small states to that in Sub-Saharan Africa (developing only)?
Provide a short and direct response. 1.01. What is the ratio of the Rating (1=low 6=high) of 2005 in Pacific island small states to that in Upper middle income?
Offer a very short reply. 0.91. What is the ratio of the Rating (1=low 6=high) in 2006 in Pacific island small states to that in Upper middle income?
Provide a short and direct response. 0.92. What is the ratio of the Rating (1=low 6=high) of 2007 in Pacific island small states to that in Upper middle income?
Provide a short and direct response. 0.94. What is the ratio of the Rating (1=low 6=high) of 2008 in Pacific island small states to that in Upper middle income?
Make the answer very short. 1.01. What is the ratio of the Rating (1=low 6=high) of 2005 in Small states to that in South Asia?
Give a very brief answer. 0.87. What is the ratio of the Rating (1=low 6=high) of 2006 in Small states to that in South Asia?
Keep it short and to the point. 0.89. What is the ratio of the Rating (1=low 6=high) of 2007 in Small states to that in South Asia?
Your answer should be very brief. 0.91. What is the ratio of the Rating (1=low 6=high) of 2008 in Small states to that in South Asia?
Provide a succinct answer. 0.94. What is the ratio of the Rating (1=low 6=high) of 2005 in Small states to that in Sub-Saharan Africa (all income levels)?
Offer a very short reply. 1.03. What is the ratio of the Rating (1=low 6=high) in 2006 in Small states to that in Sub-Saharan Africa (all income levels)?
Offer a very short reply. 1. What is the ratio of the Rating (1=low 6=high) in 2007 in Small states to that in Sub-Saharan Africa (all income levels)?
Ensure brevity in your answer.  0.99. What is the ratio of the Rating (1=low 6=high) of 2005 in Small states to that in Sub-Saharan Africa (developing only)?
Provide a succinct answer. 1.03. What is the ratio of the Rating (1=low 6=high) of 2006 in Small states to that in Sub-Saharan Africa (developing only)?
Your answer should be compact. 1. What is the ratio of the Rating (1=low 6=high) of 2008 in Small states to that in Sub-Saharan Africa (developing only)?
Offer a very short reply. 0.99. What is the ratio of the Rating (1=low 6=high) in 2005 in Small states to that in Upper middle income?
Give a very brief answer. 0.93. What is the ratio of the Rating (1=low 6=high) of 2006 in Small states to that in Upper middle income?
Your answer should be compact. 0.93. What is the ratio of the Rating (1=low 6=high) in 2008 in Small states to that in Upper middle income?
Give a very brief answer. 0.98. What is the ratio of the Rating (1=low 6=high) in 2005 in South Asia to that in Sub-Saharan Africa (all income levels)?
Offer a very short reply. 1.18. What is the ratio of the Rating (1=low 6=high) in 2006 in South Asia to that in Sub-Saharan Africa (all income levels)?
Give a very brief answer. 1.13. What is the ratio of the Rating (1=low 6=high) of 2007 in South Asia to that in Sub-Saharan Africa (all income levels)?
Your answer should be very brief. 1.09. What is the ratio of the Rating (1=low 6=high) of 2008 in South Asia to that in Sub-Saharan Africa (all income levels)?
Your response must be concise. 1.05. What is the ratio of the Rating (1=low 6=high) of 2005 in South Asia to that in Sub-Saharan Africa (developing only)?
Your response must be concise. 1.18. What is the ratio of the Rating (1=low 6=high) in 2006 in South Asia to that in Sub-Saharan Africa (developing only)?
Keep it short and to the point. 1.13. What is the ratio of the Rating (1=low 6=high) of 2007 in South Asia to that in Sub-Saharan Africa (developing only)?
Ensure brevity in your answer.  1.09. What is the ratio of the Rating (1=low 6=high) in 2008 in South Asia to that in Sub-Saharan Africa (developing only)?
Ensure brevity in your answer.  1.05. What is the ratio of the Rating (1=low 6=high) of 2005 in South Asia to that in Upper middle income?
Offer a very short reply. 1.07. What is the ratio of the Rating (1=low 6=high) in 2006 in South Asia to that in Upper middle income?
Offer a terse response. 1.04. What is the ratio of the Rating (1=low 6=high) of 2007 in South Asia to that in Upper middle income?
Provide a short and direct response. 1.05. What is the ratio of the Rating (1=low 6=high) in 2008 in South Asia to that in Upper middle income?
Make the answer very short. 1.05. What is the ratio of the Rating (1=low 6=high) of 2005 in Sub-Saharan Africa (all income levels) to that in Sub-Saharan Africa (developing only)?
Provide a succinct answer. 1. What is the ratio of the Rating (1=low 6=high) in 2006 in Sub-Saharan Africa (all income levels) to that in Sub-Saharan Africa (developing only)?
Make the answer very short. 1. What is the ratio of the Rating (1=low 6=high) in 2008 in Sub-Saharan Africa (all income levels) to that in Sub-Saharan Africa (developing only)?
Your response must be concise. 1. What is the ratio of the Rating (1=low 6=high) of 2005 in Sub-Saharan Africa (all income levels) to that in Upper middle income?
Give a very brief answer. 0.9. What is the ratio of the Rating (1=low 6=high) in 2006 in Sub-Saharan Africa (all income levels) to that in Upper middle income?
Your answer should be compact. 0.93. What is the ratio of the Rating (1=low 6=high) in 2007 in Sub-Saharan Africa (all income levels) to that in Upper middle income?
Keep it short and to the point. 0.96. What is the ratio of the Rating (1=low 6=high) in 2008 in Sub-Saharan Africa (all income levels) to that in Upper middle income?
Give a very brief answer. 1. What is the ratio of the Rating (1=low 6=high) in 2005 in Sub-Saharan Africa (developing only) to that in Upper middle income?
Offer a very short reply. 0.9. What is the ratio of the Rating (1=low 6=high) in 2006 in Sub-Saharan Africa (developing only) to that in Upper middle income?
Make the answer very short. 0.93. What is the ratio of the Rating (1=low 6=high) of 2007 in Sub-Saharan Africa (developing only) to that in Upper middle income?
Give a very brief answer. 0.96. What is the difference between the highest and the second highest Rating (1=low 6=high) in 2005?
Your answer should be very brief. 0.24. What is the difference between the highest and the second highest Rating (1=low 6=high) of 2006?
Make the answer very short. 0.15. What is the difference between the highest and the second highest Rating (1=low 6=high) in 2007?
Provide a succinct answer. 0.17. What is the difference between the highest and the second highest Rating (1=low 6=high) in 2008?
Give a very brief answer. 0.14. What is the difference between the highest and the lowest Rating (1=low 6=high) in 2005?
Ensure brevity in your answer.  0.6. What is the difference between the highest and the lowest Rating (1=low 6=high) of 2006?
Your answer should be compact. 0.44. What is the difference between the highest and the lowest Rating (1=low 6=high) in 2007?
Offer a very short reply. 0.37. What is the difference between the highest and the lowest Rating (1=low 6=high) in 2008?
Offer a terse response. 0.21. 